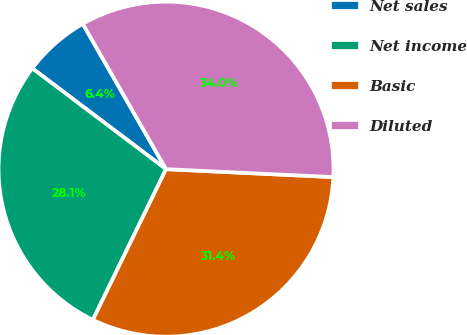Convert chart to OTSL. <chart><loc_0><loc_0><loc_500><loc_500><pie_chart><fcel>Net sales<fcel>Net income<fcel>Basic<fcel>Diluted<nl><fcel>6.44%<fcel>28.09%<fcel>31.44%<fcel>34.03%<nl></chart> 